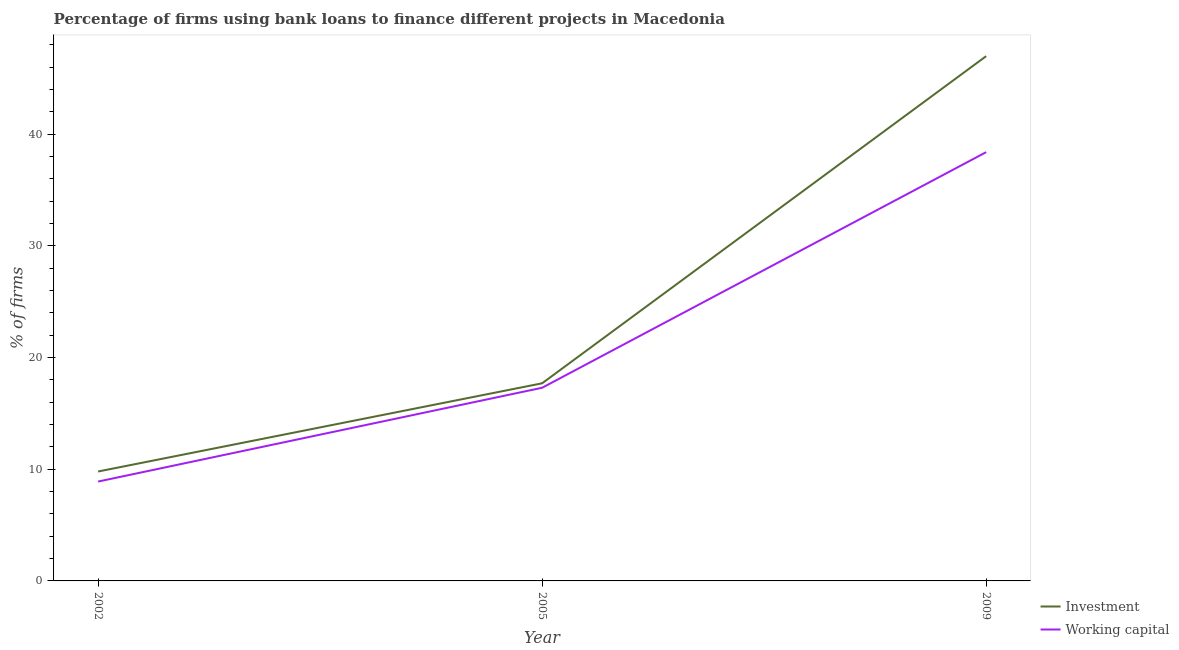How many different coloured lines are there?
Give a very brief answer. 2. Does the line corresponding to percentage of firms using banks to finance investment intersect with the line corresponding to percentage of firms using banks to finance working capital?
Provide a succinct answer. No. Is the number of lines equal to the number of legend labels?
Keep it short and to the point. Yes. Across all years, what is the maximum percentage of firms using banks to finance investment?
Your response must be concise. 47. In which year was the percentage of firms using banks to finance working capital minimum?
Offer a very short reply. 2002. What is the total percentage of firms using banks to finance working capital in the graph?
Offer a terse response. 64.6. What is the difference between the percentage of firms using banks to finance investment in 2002 and that in 2009?
Your answer should be very brief. -37.2. What is the difference between the percentage of firms using banks to finance working capital in 2009 and the percentage of firms using banks to finance investment in 2005?
Provide a short and direct response. 20.7. What is the average percentage of firms using banks to finance working capital per year?
Your answer should be very brief. 21.53. In the year 2009, what is the difference between the percentage of firms using banks to finance investment and percentage of firms using banks to finance working capital?
Your answer should be very brief. 8.6. What is the ratio of the percentage of firms using banks to finance working capital in 2002 to that in 2005?
Offer a terse response. 0.51. What is the difference between the highest and the second highest percentage of firms using banks to finance investment?
Offer a terse response. 29.3. What is the difference between the highest and the lowest percentage of firms using banks to finance investment?
Offer a terse response. 37.2. Is the percentage of firms using banks to finance investment strictly greater than the percentage of firms using banks to finance working capital over the years?
Make the answer very short. Yes. Is the percentage of firms using banks to finance working capital strictly less than the percentage of firms using banks to finance investment over the years?
Ensure brevity in your answer.  Yes. How many lines are there?
Offer a very short reply. 2. How many years are there in the graph?
Give a very brief answer. 3. What is the difference between two consecutive major ticks on the Y-axis?
Offer a very short reply. 10. Does the graph contain any zero values?
Keep it short and to the point. No. Where does the legend appear in the graph?
Provide a short and direct response. Bottom right. How many legend labels are there?
Offer a terse response. 2. What is the title of the graph?
Keep it short and to the point. Percentage of firms using bank loans to finance different projects in Macedonia. Does "Forest land" appear as one of the legend labels in the graph?
Keep it short and to the point. No. What is the label or title of the Y-axis?
Keep it short and to the point. % of firms. What is the % of firms of Investment in 2002?
Offer a terse response. 9.8. What is the % of firms in Working capital in 2002?
Make the answer very short. 8.9. What is the % of firms in Working capital in 2005?
Your answer should be very brief. 17.3. What is the % of firms in Working capital in 2009?
Your response must be concise. 38.4. Across all years, what is the maximum % of firms in Working capital?
Make the answer very short. 38.4. Across all years, what is the minimum % of firms in Investment?
Offer a very short reply. 9.8. Across all years, what is the minimum % of firms in Working capital?
Your response must be concise. 8.9. What is the total % of firms in Investment in the graph?
Offer a terse response. 74.5. What is the total % of firms in Working capital in the graph?
Keep it short and to the point. 64.6. What is the difference between the % of firms in Working capital in 2002 and that in 2005?
Keep it short and to the point. -8.4. What is the difference between the % of firms of Investment in 2002 and that in 2009?
Offer a very short reply. -37.2. What is the difference between the % of firms of Working capital in 2002 and that in 2009?
Offer a terse response. -29.5. What is the difference between the % of firms in Investment in 2005 and that in 2009?
Give a very brief answer. -29.3. What is the difference between the % of firms in Working capital in 2005 and that in 2009?
Provide a succinct answer. -21.1. What is the difference between the % of firms of Investment in 2002 and the % of firms of Working capital in 2009?
Give a very brief answer. -28.6. What is the difference between the % of firms in Investment in 2005 and the % of firms in Working capital in 2009?
Your answer should be compact. -20.7. What is the average % of firms of Investment per year?
Keep it short and to the point. 24.83. What is the average % of firms of Working capital per year?
Keep it short and to the point. 21.53. In the year 2009, what is the difference between the % of firms of Investment and % of firms of Working capital?
Offer a terse response. 8.6. What is the ratio of the % of firms of Investment in 2002 to that in 2005?
Keep it short and to the point. 0.55. What is the ratio of the % of firms in Working capital in 2002 to that in 2005?
Provide a succinct answer. 0.51. What is the ratio of the % of firms of Investment in 2002 to that in 2009?
Your response must be concise. 0.21. What is the ratio of the % of firms in Working capital in 2002 to that in 2009?
Make the answer very short. 0.23. What is the ratio of the % of firms of Investment in 2005 to that in 2009?
Give a very brief answer. 0.38. What is the ratio of the % of firms in Working capital in 2005 to that in 2009?
Provide a succinct answer. 0.45. What is the difference between the highest and the second highest % of firms in Investment?
Keep it short and to the point. 29.3. What is the difference between the highest and the second highest % of firms in Working capital?
Your answer should be very brief. 21.1. What is the difference between the highest and the lowest % of firms in Investment?
Your answer should be very brief. 37.2. What is the difference between the highest and the lowest % of firms in Working capital?
Offer a very short reply. 29.5. 